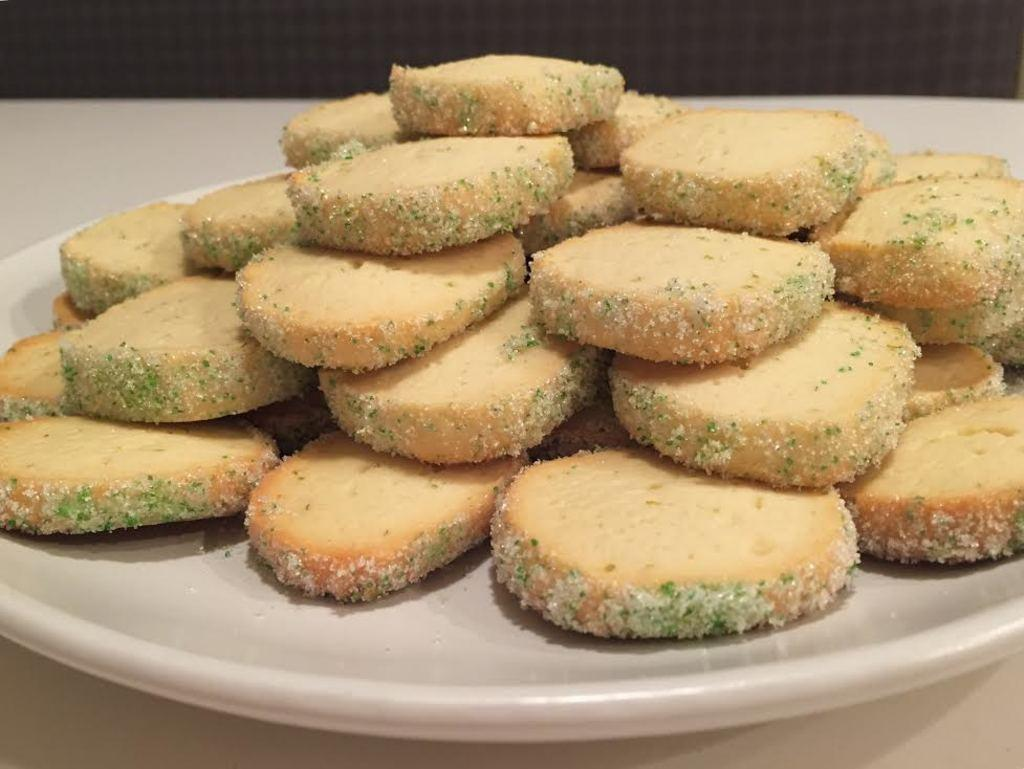What is located at the bottom of the image? There is a plate at the bottom of the image. What is on the plate? There are biscuits on the plate. What type of books can be seen on the plate? There are no books present on the plate; it contains biscuits. Is the cook visible in the image? There is no cook present in the image. 